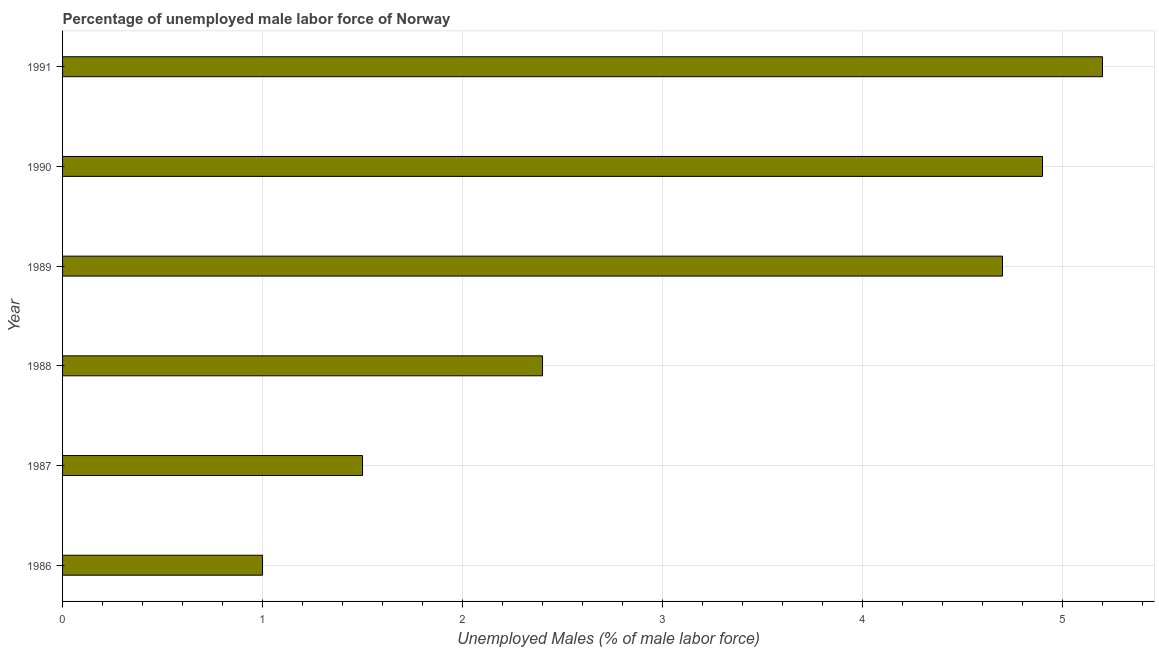Does the graph contain grids?
Your response must be concise. Yes. What is the title of the graph?
Offer a terse response. Percentage of unemployed male labor force of Norway. What is the label or title of the X-axis?
Provide a short and direct response. Unemployed Males (% of male labor force). Across all years, what is the maximum total unemployed male labour force?
Keep it short and to the point. 5.2. In which year was the total unemployed male labour force minimum?
Make the answer very short. 1986. What is the sum of the total unemployed male labour force?
Give a very brief answer. 19.7. What is the difference between the total unemployed male labour force in 1988 and 1989?
Provide a succinct answer. -2.3. What is the average total unemployed male labour force per year?
Offer a very short reply. 3.28. What is the median total unemployed male labour force?
Your response must be concise. 3.55. In how many years, is the total unemployed male labour force greater than 3 %?
Offer a terse response. 3. What is the ratio of the total unemployed male labour force in 1989 to that in 1991?
Your answer should be very brief. 0.9. Is the total unemployed male labour force in 1990 less than that in 1991?
Provide a short and direct response. Yes. How many bars are there?
Your answer should be compact. 6. Are all the bars in the graph horizontal?
Give a very brief answer. Yes. How many years are there in the graph?
Keep it short and to the point. 6. What is the difference between two consecutive major ticks on the X-axis?
Offer a terse response. 1. What is the Unemployed Males (% of male labor force) in 1988?
Ensure brevity in your answer.  2.4. What is the Unemployed Males (% of male labor force) of 1989?
Provide a short and direct response. 4.7. What is the Unemployed Males (% of male labor force) in 1990?
Provide a short and direct response. 4.9. What is the Unemployed Males (% of male labor force) of 1991?
Your answer should be very brief. 5.2. What is the difference between the Unemployed Males (% of male labor force) in 1986 and 1987?
Offer a very short reply. -0.5. What is the difference between the Unemployed Males (% of male labor force) in 1986 and 1990?
Give a very brief answer. -3.9. What is the difference between the Unemployed Males (% of male labor force) in 1987 and 1988?
Your answer should be very brief. -0.9. What is the difference between the Unemployed Males (% of male labor force) in 1987 and 1991?
Keep it short and to the point. -3.7. What is the difference between the Unemployed Males (% of male labor force) in 1988 and 1991?
Provide a short and direct response. -2.8. What is the difference between the Unemployed Males (% of male labor force) in 1989 and 1991?
Give a very brief answer. -0.5. What is the difference between the Unemployed Males (% of male labor force) in 1990 and 1991?
Provide a short and direct response. -0.3. What is the ratio of the Unemployed Males (% of male labor force) in 1986 to that in 1987?
Provide a succinct answer. 0.67. What is the ratio of the Unemployed Males (% of male labor force) in 1986 to that in 1988?
Give a very brief answer. 0.42. What is the ratio of the Unemployed Males (% of male labor force) in 1986 to that in 1989?
Provide a short and direct response. 0.21. What is the ratio of the Unemployed Males (% of male labor force) in 1986 to that in 1990?
Your answer should be very brief. 0.2. What is the ratio of the Unemployed Males (% of male labor force) in 1986 to that in 1991?
Ensure brevity in your answer.  0.19. What is the ratio of the Unemployed Males (% of male labor force) in 1987 to that in 1989?
Give a very brief answer. 0.32. What is the ratio of the Unemployed Males (% of male labor force) in 1987 to that in 1990?
Ensure brevity in your answer.  0.31. What is the ratio of the Unemployed Males (% of male labor force) in 1987 to that in 1991?
Keep it short and to the point. 0.29. What is the ratio of the Unemployed Males (% of male labor force) in 1988 to that in 1989?
Your answer should be very brief. 0.51. What is the ratio of the Unemployed Males (% of male labor force) in 1988 to that in 1990?
Give a very brief answer. 0.49. What is the ratio of the Unemployed Males (% of male labor force) in 1988 to that in 1991?
Provide a short and direct response. 0.46. What is the ratio of the Unemployed Males (% of male labor force) in 1989 to that in 1991?
Your answer should be very brief. 0.9. What is the ratio of the Unemployed Males (% of male labor force) in 1990 to that in 1991?
Ensure brevity in your answer.  0.94. 